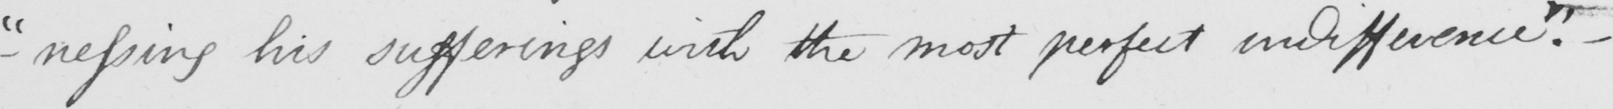What text is written in this handwritten line? " -nessing his sufferings with the most perfect indifference . "   _ 